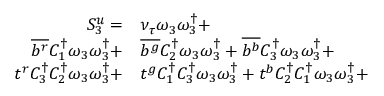<formula> <loc_0><loc_0><loc_500><loc_500>\begin{array} { r l } { S _ { 3 } ^ { u } = } & { \nu _ { \tau } } \omega _ { 3 } \omega _ { 3 } ^ { \dagger } + } \\ { \overline { { b ^ { r } } } { C _ { 1 } ^ { \dagger } } \omega _ { 3 } \omega _ { 3 } ^ { \dagger } + } & \overline { { b ^ { g } } } { C _ { 2 } ^ { \dagger } } \omega _ { 3 } \omega _ { 3 } ^ { \dagger } + \overline { { b ^ { b } } } { C _ { 3 } ^ { \dagger } } \omega _ { 3 } \omega _ { 3 } ^ { \dagger } + } \\ { t ^ { r } { C _ { 3 } ^ { \dagger } } { C _ { 2 } ^ { \dagger } } \omega _ { 3 } \omega _ { 3 } ^ { \dagger } + } & t ^ { g } { C _ { 1 } ^ { \dagger } } { C _ { 3 } ^ { \dagger } } \omega _ { 3 } \omega _ { 3 } ^ { \dagger } + t ^ { b } { C _ { 2 } ^ { \dagger } } { C _ { 1 } ^ { \dagger } } \omega _ { 3 } \omega _ { 3 } ^ { \dagger } + } \end{array}</formula> 